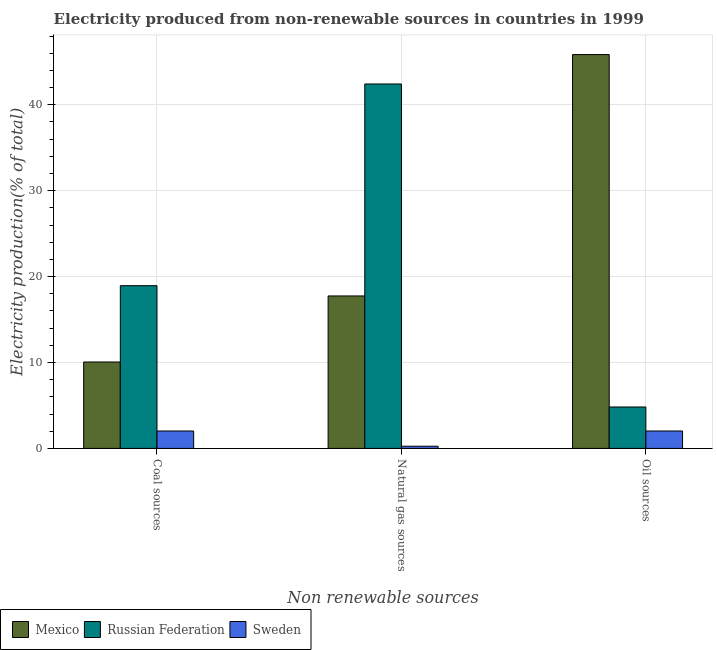How many different coloured bars are there?
Provide a succinct answer. 3. How many groups of bars are there?
Give a very brief answer. 3. Are the number of bars per tick equal to the number of legend labels?
Provide a succinct answer. Yes. Are the number of bars on each tick of the X-axis equal?
Make the answer very short. Yes. How many bars are there on the 3rd tick from the left?
Offer a very short reply. 3. How many bars are there on the 3rd tick from the right?
Provide a succinct answer. 3. What is the label of the 3rd group of bars from the left?
Your answer should be compact. Oil sources. What is the percentage of electricity produced by oil sources in Sweden?
Make the answer very short. 2.03. Across all countries, what is the maximum percentage of electricity produced by natural gas?
Offer a terse response. 42.42. Across all countries, what is the minimum percentage of electricity produced by coal?
Give a very brief answer. 2.03. In which country was the percentage of electricity produced by oil sources maximum?
Your response must be concise. Mexico. What is the total percentage of electricity produced by oil sources in the graph?
Offer a terse response. 52.7. What is the difference between the percentage of electricity produced by coal in Mexico and that in Russian Federation?
Provide a short and direct response. -8.88. What is the difference between the percentage of electricity produced by natural gas in Russian Federation and the percentage of electricity produced by coal in Sweden?
Your answer should be compact. 40.4. What is the average percentage of electricity produced by natural gas per country?
Your answer should be very brief. 20.14. What is the difference between the percentage of electricity produced by coal and percentage of electricity produced by natural gas in Mexico?
Your answer should be very brief. -7.69. What is the ratio of the percentage of electricity produced by oil sources in Mexico to that in Russian Federation?
Offer a very short reply. 9.51. What is the difference between the highest and the second highest percentage of electricity produced by oil sources?
Your answer should be compact. 41.03. What is the difference between the highest and the lowest percentage of electricity produced by natural gas?
Give a very brief answer. 42.17. In how many countries, is the percentage of electricity produced by natural gas greater than the average percentage of electricity produced by natural gas taken over all countries?
Your response must be concise. 1. What does the 2nd bar from the left in Coal sources represents?
Make the answer very short. Russian Federation. What does the 3rd bar from the right in Natural gas sources represents?
Offer a very short reply. Mexico. Are all the bars in the graph horizontal?
Provide a short and direct response. No. Are the values on the major ticks of Y-axis written in scientific E-notation?
Give a very brief answer. No. Does the graph contain any zero values?
Keep it short and to the point. No. Does the graph contain grids?
Your answer should be compact. Yes. Where does the legend appear in the graph?
Offer a terse response. Bottom left. How are the legend labels stacked?
Make the answer very short. Horizontal. What is the title of the graph?
Offer a very short reply. Electricity produced from non-renewable sources in countries in 1999. Does "Romania" appear as one of the legend labels in the graph?
Your answer should be very brief. No. What is the label or title of the X-axis?
Ensure brevity in your answer.  Non renewable sources. What is the Electricity production(% of total) in Mexico in Coal sources?
Offer a very short reply. 10.06. What is the Electricity production(% of total) in Russian Federation in Coal sources?
Provide a short and direct response. 18.94. What is the Electricity production(% of total) of Sweden in Coal sources?
Offer a very short reply. 2.03. What is the Electricity production(% of total) of Mexico in Natural gas sources?
Your answer should be very brief. 17.75. What is the Electricity production(% of total) of Russian Federation in Natural gas sources?
Provide a short and direct response. 42.42. What is the Electricity production(% of total) in Sweden in Natural gas sources?
Provide a succinct answer. 0.26. What is the Electricity production(% of total) of Mexico in Oil sources?
Offer a terse response. 45.85. What is the Electricity production(% of total) in Russian Federation in Oil sources?
Provide a short and direct response. 4.82. What is the Electricity production(% of total) in Sweden in Oil sources?
Provide a short and direct response. 2.03. Across all Non renewable sources, what is the maximum Electricity production(% of total) of Mexico?
Your answer should be compact. 45.85. Across all Non renewable sources, what is the maximum Electricity production(% of total) of Russian Federation?
Ensure brevity in your answer.  42.42. Across all Non renewable sources, what is the maximum Electricity production(% of total) of Sweden?
Ensure brevity in your answer.  2.03. Across all Non renewable sources, what is the minimum Electricity production(% of total) in Mexico?
Provide a succinct answer. 10.06. Across all Non renewable sources, what is the minimum Electricity production(% of total) of Russian Federation?
Give a very brief answer. 4.82. Across all Non renewable sources, what is the minimum Electricity production(% of total) in Sweden?
Make the answer very short. 0.26. What is the total Electricity production(% of total) of Mexico in the graph?
Make the answer very short. 73.66. What is the total Electricity production(% of total) of Russian Federation in the graph?
Your answer should be very brief. 66.19. What is the total Electricity production(% of total) in Sweden in the graph?
Provide a succinct answer. 4.31. What is the difference between the Electricity production(% of total) of Mexico in Coal sources and that in Natural gas sources?
Your response must be concise. -7.69. What is the difference between the Electricity production(% of total) in Russian Federation in Coal sources and that in Natural gas sources?
Provide a succinct answer. -23.48. What is the difference between the Electricity production(% of total) of Sweden in Coal sources and that in Natural gas sources?
Provide a short and direct response. 1.77. What is the difference between the Electricity production(% of total) in Mexico in Coal sources and that in Oil sources?
Your answer should be very brief. -35.79. What is the difference between the Electricity production(% of total) in Russian Federation in Coal sources and that in Oil sources?
Your answer should be very brief. 14.12. What is the difference between the Electricity production(% of total) of Mexico in Natural gas sources and that in Oil sources?
Provide a short and direct response. -28.1. What is the difference between the Electricity production(% of total) of Russian Federation in Natural gas sources and that in Oil sources?
Provide a succinct answer. 37.6. What is the difference between the Electricity production(% of total) of Sweden in Natural gas sources and that in Oil sources?
Provide a succinct answer. -1.77. What is the difference between the Electricity production(% of total) in Mexico in Coal sources and the Electricity production(% of total) in Russian Federation in Natural gas sources?
Your answer should be very brief. -32.36. What is the difference between the Electricity production(% of total) in Mexico in Coal sources and the Electricity production(% of total) in Sweden in Natural gas sources?
Offer a very short reply. 9.8. What is the difference between the Electricity production(% of total) in Russian Federation in Coal sources and the Electricity production(% of total) in Sweden in Natural gas sources?
Make the answer very short. 18.69. What is the difference between the Electricity production(% of total) of Mexico in Coal sources and the Electricity production(% of total) of Russian Federation in Oil sources?
Offer a very short reply. 5.24. What is the difference between the Electricity production(% of total) in Mexico in Coal sources and the Electricity production(% of total) in Sweden in Oil sources?
Provide a succinct answer. 8.03. What is the difference between the Electricity production(% of total) of Russian Federation in Coal sources and the Electricity production(% of total) of Sweden in Oil sources?
Your response must be concise. 16.92. What is the difference between the Electricity production(% of total) in Mexico in Natural gas sources and the Electricity production(% of total) in Russian Federation in Oil sources?
Your response must be concise. 12.93. What is the difference between the Electricity production(% of total) of Mexico in Natural gas sources and the Electricity production(% of total) of Sweden in Oil sources?
Ensure brevity in your answer.  15.72. What is the difference between the Electricity production(% of total) of Russian Federation in Natural gas sources and the Electricity production(% of total) of Sweden in Oil sources?
Your response must be concise. 40.4. What is the average Electricity production(% of total) in Mexico per Non renewable sources?
Provide a short and direct response. 24.55. What is the average Electricity production(% of total) in Russian Federation per Non renewable sources?
Make the answer very short. 22.06. What is the average Electricity production(% of total) in Sweden per Non renewable sources?
Ensure brevity in your answer.  1.44. What is the difference between the Electricity production(% of total) of Mexico and Electricity production(% of total) of Russian Federation in Coal sources?
Provide a succinct answer. -8.88. What is the difference between the Electricity production(% of total) of Mexico and Electricity production(% of total) of Sweden in Coal sources?
Your response must be concise. 8.03. What is the difference between the Electricity production(% of total) of Russian Federation and Electricity production(% of total) of Sweden in Coal sources?
Your response must be concise. 16.92. What is the difference between the Electricity production(% of total) in Mexico and Electricity production(% of total) in Russian Federation in Natural gas sources?
Offer a very short reply. -24.67. What is the difference between the Electricity production(% of total) in Mexico and Electricity production(% of total) in Sweden in Natural gas sources?
Your answer should be very brief. 17.49. What is the difference between the Electricity production(% of total) in Russian Federation and Electricity production(% of total) in Sweden in Natural gas sources?
Give a very brief answer. 42.17. What is the difference between the Electricity production(% of total) of Mexico and Electricity production(% of total) of Russian Federation in Oil sources?
Your response must be concise. 41.03. What is the difference between the Electricity production(% of total) of Mexico and Electricity production(% of total) of Sweden in Oil sources?
Your answer should be very brief. 43.82. What is the difference between the Electricity production(% of total) in Russian Federation and Electricity production(% of total) in Sweden in Oil sources?
Offer a terse response. 2.79. What is the ratio of the Electricity production(% of total) in Mexico in Coal sources to that in Natural gas sources?
Provide a short and direct response. 0.57. What is the ratio of the Electricity production(% of total) of Russian Federation in Coal sources to that in Natural gas sources?
Provide a short and direct response. 0.45. What is the ratio of the Electricity production(% of total) of Sweden in Coal sources to that in Natural gas sources?
Give a very brief answer. 7.89. What is the ratio of the Electricity production(% of total) in Mexico in Coal sources to that in Oil sources?
Ensure brevity in your answer.  0.22. What is the ratio of the Electricity production(% of total) of Russian Federation in Coal sources to that in Oil sources?
Keep it short and to the point. 3.93. What is the ratio of the Electricity production(% of total) of Sweden in Coal sources to that in Oil sources?
Offer a very short reply. 1. What is the ratio of the Electricity production(% of total) in Mexico in Natural gas sources to that in Oil sources?
Give a very brief answer. 0.39. What is the ratio of the Electricity production(% of total) in Russian Federation in Natural gas sources to that in Oil sources?
Give a very brief answer. 8.8. What is the ratio of the Electricity production(% of total) of Sweden in Natural gas sources to that in Oil sources?
Your response must be concise. 0.13. What is the difference between the highest and the second highest Electricity production(% of total) of Mexico?
Provide a short and direct response. 28.1. What is the difference between the highest and the second highest Electricity production(% of total) in Russian Federation?
Your response must be concise. 23.48. What is the difference between the highest and the second highest Electricity production(% of total) of Sweden?
Ensure brevity in your answer.  0. What is the difference between the highest and the lowest Electricity production(% of total) in Mexico?
Keep it short and to the point. 35.79. What is the difference between the highest and the lowest Electricity production(% of total) in Russian Federation?
Offer a very short reply. 37.6. What is the difference between the highest and the lowest Electricity production(% of total) in Sweden?
Make the answer very short. 1.77. 